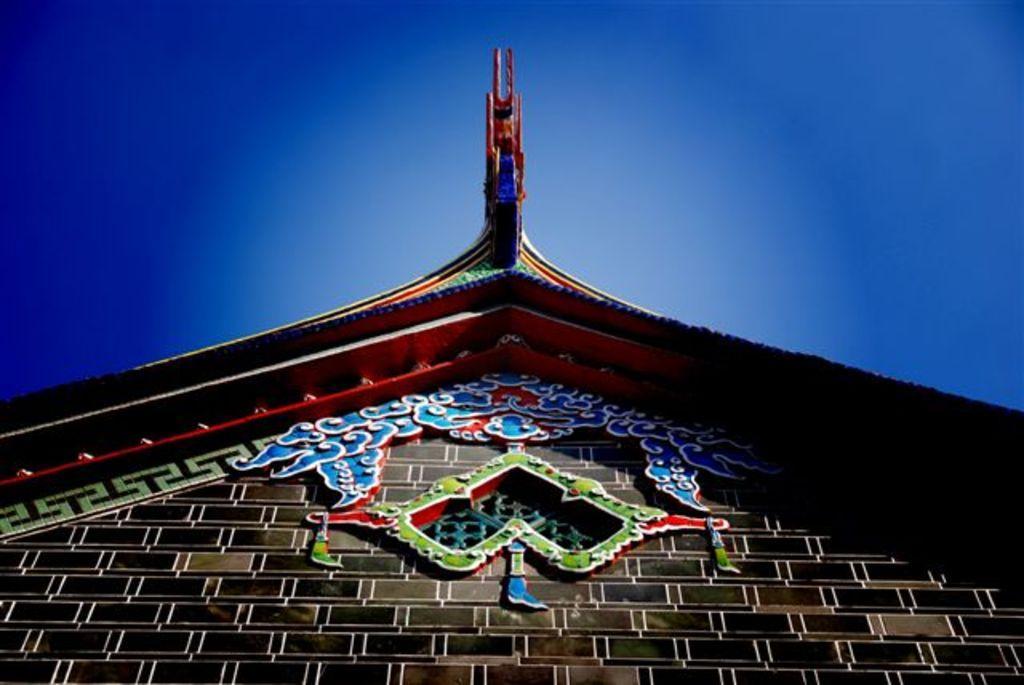Describe this image in one or two sentences. In this image we can see wall and there is roof which is in multi color and there is some decoration on the wall and top of the image there is clear sky. 